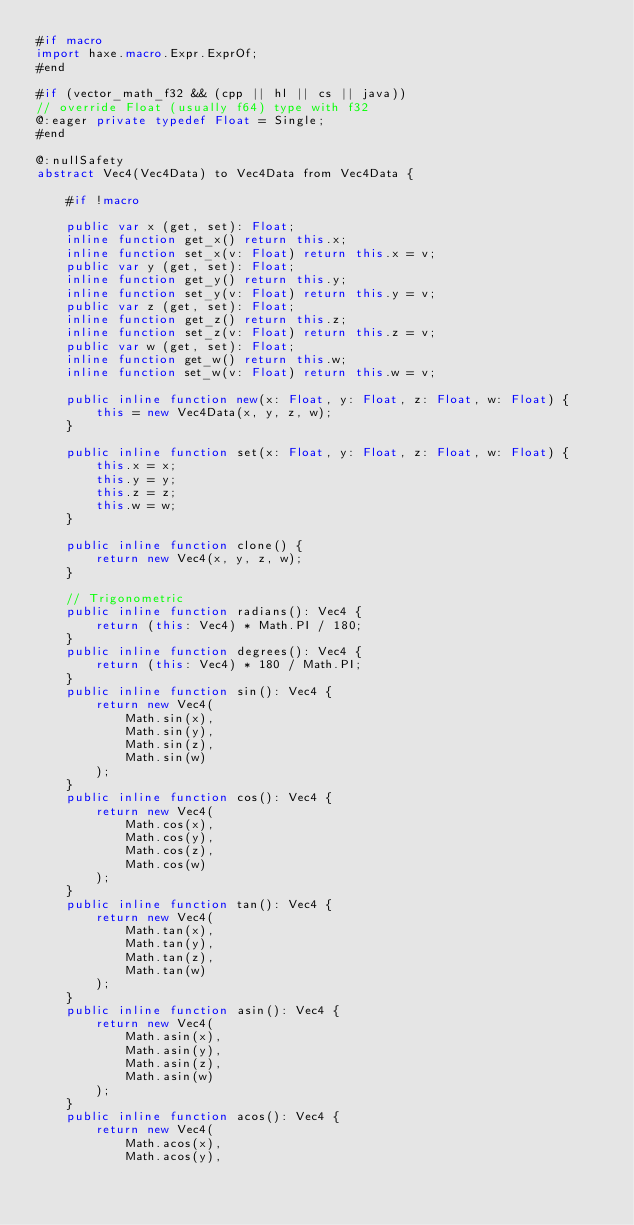<code> <loc_0><loc_0><loc_500><loc_500><_Haxe_>#if macro
import haxe.macro.Expr.ExprOf;
#end

#if (vector_math_f32 && (cpp || hl || cs || java))
// override Float (usually f64) type with f32
@:eager private typedef Float = Single;
#end

@:nullSafety
abstract Vec4(Vec4Data) to Vec4Data from Vec4Data {

	#if !macro

	public var x (get, set): Float;
	inline function get_x() return this.x;
	inline function set_x(v: Float) return this.x = v;
	public var y (get, set): Float;
	inline function get_y() return this.y;
	inline function set_y(v: Float) return this.y = v;
	public var z (get, set): Float;
	inline function get_z() return this.z;
	inline function set_z(v: Float) return this.z = v;
	public var w (get, set): Float;
	inline function get_w() return this.w;
	inline function set_w(v: Float) return this.w = v;

	public inline function new(x: Float, y: Float, z: Float, w: Float) {
		this = new Vec4Data(x, y, z, w);
	}

	public inline function set(x: Float, y: Float, z: Float, w: Float) {
		this.x = x;
		this.y = y;
		this.z = z;
		this.w = w;
	}

	public inline function clone() {
		return new Vec4(x, y, z, w);
	}

	// Trigonometric
	public inline function radians(): Vec4 {
		return (this: Vec4) * Math.PI / 180;
	}
	public inline function degrees(): Vec4 {
		return (this: Vec4) * 180 / Math.PI;
	}
	public inline function sin(): Vec4 {
		return new Vec4(
			Math.sin(x),
			Math.sin(y),
			Math.sin(z),
			Math.sin(w)
		);
	}
	public inline function cos(): Vec4 {
		return new Vec4(
			Math.cos(x),
			Math.cos(y),
			Math.cos(z),
			Math.cos(w)
		);
	}
	public inline function tan(): Vec4 {
		return new Vec4(
			Math.tan(x),
			Math.tan(y),
			Math.tan(z),
			Math.tan(w)
		);
	}
	public inline function asin(): Vec4 {
		return new Vec4(
			Math.asin(x),
			Math.asin(y),
			Math.asin(z),
			Math.asin(w)
		);
	}
	public inline function acos(): Vec4 {
		return new Vec4(
			Math.acos(x),
			Math.acos(y),</code> 